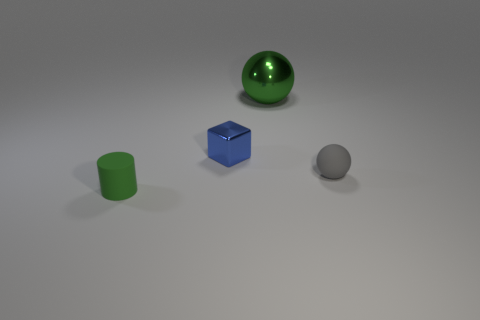Add 2 cylinders. How many objects exist? 6 Subtract all cylinders. How many objects are left? 3 Add 1 brown metal blocks. How many brown metal blocks exist? 1 Subtract 0 yellow cylinders. How many objects are left? 4 Subtract all large blue blocks. Subtract all tiny metal objects. How many objects are left? 3 Add 3 green shiny spheres. How many green shiny spheres are left? 4 